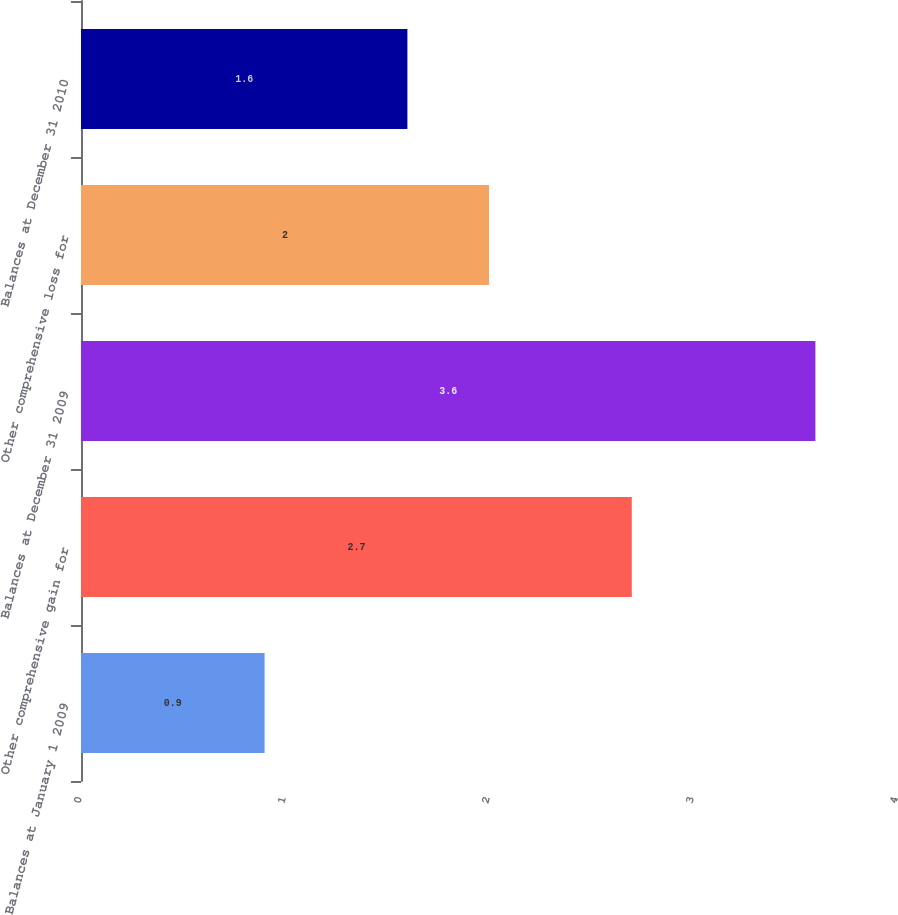<chart> <loc_0><loc_0><loc_500><loc_500><bar_chart><fcel>Balances at January 1 2009<fcel>Other comprehensive gain for<fcel>Balances at December 31 2009<fcel>Other comprehensive loss for<fcel>Balances at December 31 2010<nl><fcel>0.9<fcel>2.7<fcel>3.6<fcel>2<fcel>1.6<nl></chart> 